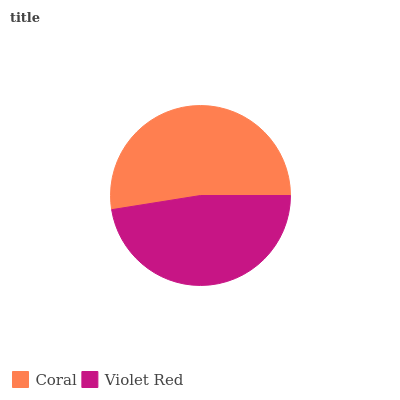Is Violet Red the minimum?
Answer yes or no. Yes. Is Coral the maximum?
Answer yes or no. Yes. Is Violet Red the maximum?
Answer yes or no. No. Is Coral greater than Violet Red?
Answer yes or no. Yes. Is Violet Red less than Coral?
Answer yes or no. Yes. Is Violet Red greater than Coral?
Answer yes or no. No. Is Coral less than Violet Red?
Answer yes or no. No. Is Coral the high median?
Answer yes or no. Yes. Is Violet Red the low median?
Answer yes or no. Yes. Is Violet Red the high median?
Answer yes or no. No. Is Coral the low median?
Answer yes or no. No. 